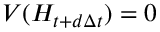<formula> <loc_0><loc_0><loc_500><loc_500>V ( H _ { t + d \Delta t } ) = 0</formula> 